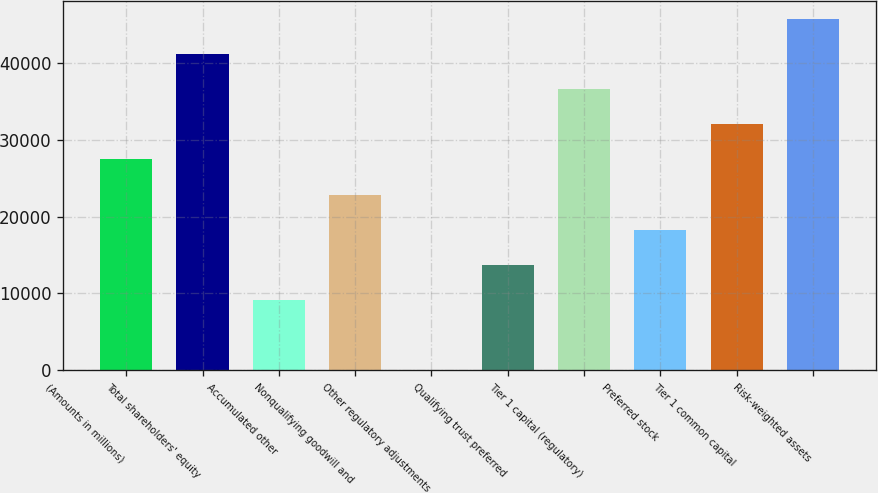<chart> <loc_0><loc_0><loc_500><loc_500><bar_chart><fcel>(Amounts in millions)<fcel>Total shareholders' equity<fcel>Accumulated other<fcel>Nonqualifying goodwill and<fcel>Other regulatory adjustments<fcel>Qualifying trust preferred<fcel>Tier 1 capital (regulatory)<fcel>Preferred stock<fcel>Tier 1 common capital<fcel>Risk-weighted assets<nl><fcel>27443.2<fcel>41164.3<fcel>9148.4<fcel>22869.5<fcel>1<fcel>13722.1<fcel>36590.6<fcel>18295.8<fcel>32016.9<fcel>45738<nl></chart> 